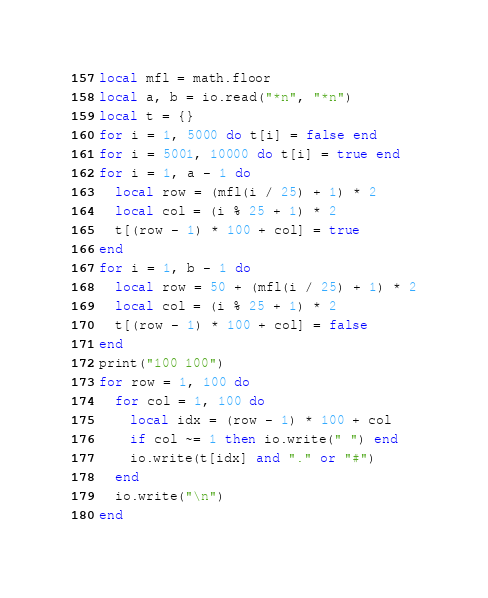Convert code to text. <code><loc_0><loc_0><loc_500><loc_500><_Lua_>local mfl = math.floor
local a, b = io.read("*n", "*n")
local t = {}
for i = 1, 5000 do t[i] = false end
for i = 5001, 10000 do t[i] = true end
for i = 1, a - 1 do
  local row = (mfl(i / 25) + 1) * 2
  local col = (i % 25 + 1) * 2
  t[(row - 1) * 100 + col] = true
end
for i = 1, b - 1 do
  local row = 50 + (mfl(i / 25) + 1) * 2
  local col = (i % 25 + 1) * 2
  t[(row - 1) * 100 + col] = false
end
print("100 100")
for row = 1, 100 do
  for col = 1, 100 do
    local idx = (row - 1) * 100 + col
    if col ~= 1 then io.write(" ") end
    io.write(t[idx] and "." or "#")
  end
  io.write("\n")
end
</code> 